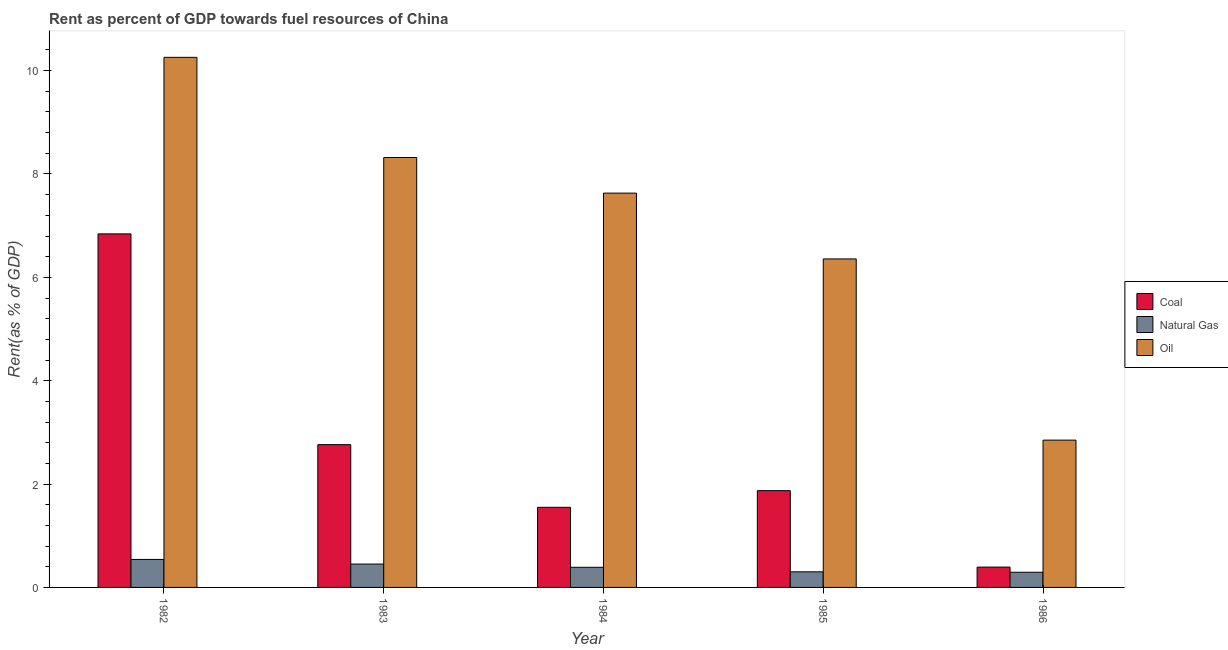How many different coloured bars are there?
Your answer should be compact. 3. How many groups of bars are there?
Your answer should be compact. 5. How many bars are there on the 2nd tick from the left?
Provide a succinct answer. 3. What is the rent towards coal in 1984?
Give a very brief answer. 1.55. Across all years, what is the maximum rent towards oil?
Give a very brief answer. 10.26. Across all years, what is the minimum rent towards oil?
Keep it short and to the point. 2.85. What is the total rent towards oil in the graph?
Your answer should be very brief. 35.41. What is the difference between the rent towards oil in 1982 and that in 1986?
Provide a succinct answer. 7.41. What is the difference between the rent towards coal in 1985 and the rent towards oil in 1984?
Give a very brief answer. 0.32. What is the average rent towards natural gas per year?
Give a very brief answer. 0.4. What is the ratio of the rent towards oil in 1984 to that in 1986?
Give a very brief answer. 2.68. Is the difference between the rent towards oil in 1982 and 1986 greater than the difference between the rent towards coal in 1982 and 1986?
Your response must be concise. No. What is the difference between the highest and the second highest rent towards natural gas?
Keep it short and to the point. 0.09. What is the difference between the highest and the lowest rent towards coal?
Provide a short and direct response. 6.45. In how many years, is the rent towards natural gas greater than the average rent towards natural gas taken over all years?
Make the answer very short. 2. What does the 1st bar from the left in 1983 represents?
Ensure brevity in your answer.  Coal. What does the 3rd bar from the right in 1986 represents?
Make the answer very short. Coal. Are all the bars in the graph horizontal?
Your response must be concise. No. How many years are there in the graph?
Your response must be concise. 5. What is the difference between two consecutive major ticks on the Y-axis?
Ensure brevity in your answer.  2. Does the graph contain any zero values?
Your answer should be very brief. No. Where does the legend appear in the graph?
Offer a terse response. Center right. How many legend labels are there?
Your response must be concise. 3. What is the title of the graph?
Provide a succinct answer. Rent as percent of GDP towards fuel resources of China. What is the label or title of the Y-axis?
Provide a succinct answer. Rent(as % of GDP). What is the Rent(as % of GDP) of Coal in 1982?
Give a very brief answer. 6.84. What is the Rent(as % of GDP) of Natural Gas in 1982?
Provide a short and direct response. 0.54. What is the Rent(as % of GDP) in Oil in 1982?
Provide a succinct answer. 10.26. What is the Rent(as % of GDP) in Coal in 1983?
Offer a very short reply. 2.76. What is the Rent(as % of GDP) of Natural Gas in 1983?
Offer a terse response. 0.45. What is the Rent(as % of GDP) in Oil in 1983?
Offer a very short reply. 8.32. What is the Rent(as % of GDP) of Coal in 1984?
Offer a terse response. 1.55. What is the Rent(as % of GDP) in Natural Gas in 1984?
Give a very brief answer. 0.39. What is the Rent(as % of GDP) in Oil in 1984?
Provide a short and direct response. 7.63. What is the Rent(as % of GDP) in Coal in 1985?
Offer a terse response. 1.87. What is the Rent(as % of GDP) in Natural Gas in 1985?
Provide a succinct answer. 0.3. What is the Rent(as % of GDP) in Oil in 1985?
Offer a terse response. 6.36. What is the Rent(as % of GDP) in Coal in 1986?
Your response must be concise. 0.39. What is the Rent(as % of GDP) in Natural Gas in 1986?
Provide a short and direct response. 0.29. What is the Rent(as % of GDP) in Oil in 1986?
Provide a short and direct response. 2.85. Across all years, what is the maximum Rent(as % of GDP) of Coal?
Your answer should be very brief. 6.84. Across all years, what is the maximum Rent(as % of GDP) of Natural Gas?
Give a very brief answer. 0.54. Across all years, what is the maximum Rent(as % of GDP) in Oil?
Provide a succinct answer. 10.26. Across all years, what is the minimum Rent(as % of GDP) of Coal?
Ensure brevity in your answer.  0.39. Across all years, what is the minimum Rent(as % of GDP) of Natural Gas?
Your response must be concise. 0.29. Across all years, what is the minimum Rent(as % of GDP) of Oil?
Make the answer very short. 2.85. What is the total Rent(as % of GDP) in Coal in the graph?
Keep it short and to the point. 13.42. What is the total Rent(as % of GDP) of Natural Gas in the graph?
Ensure brevity in your answer.  1.98. What is the total Rent(as % of GDP) in Oil in the graph?
Provide a succinct answer. 35.41. What is the difference between the Rent(as % of GDP) in Coal in 1982 and that in 1983?
Your response must be concise. 4.08. What is the difference between the Rent(as % of GDP) in Natural Gas in 1982 and that in 1983?
Give a very brief answer. 0.09. What is the difference between the Rent(as % of GDP) in Oil in 1982 and that in 1983?
Provide a succinct answer. 1.94. What is the difference between the Rent(as % of GDP) of Coal in 1982 and that in 1984?
Your answer should be compact. 5.29. What is the difference between the Rent(as % of GDP) of Natural Gas in 1982 and that in 1984?
Give a very brief answer. 0.15. What is the difference between the Rent(as % of GDP) of Oil in 1982 and that in 1984?
Give a very brief answer. 2.63. What is the difference between the Rent(as % of GDP) in Coal in 1982 and that in 1985?
Provide a succinct answer. 4.97. What is the difference between the Rent(as % of GDP) in Natural Gas in 1982 and that in 1985?
Your answer should be compact. 0.24. What is the difference between the Rent(as % of GDP) in Oil in 1982 and that in 1985?
Ensure brevity in your answer.  3.9. What is the difference between the Rent(as % of GDP) of Coal in 1982 and that in 1986?
Make the answer very short. 6.45. What is the difference between the Rent(as % of GDP) of Natural Gas in 1982 and that in 1986?
Provide a short and direct response. 0.25. What is the difference between the Rent(as % of GDP) of Oil in 1982 and that in 1986?
Give a very brief answer. 7.41. What is the difference between the Rent(as % of GDP) of Coal in 1983 and that in 1984?
Keep it short and to the point. 1.21. What is the difference between the Rent(as % of GDP) of Natural Gas in 1983 and that in 1984?
Ensure brevity in your answer.  0.06. What is the difference between the Rent(as % of GDP) of Oil in 1983 and that in 1984?
Offer a very short reply. 0.69. What is the difference between the Rent(as % of GDP) of Coal in 1983 and that in 1985?
Your response must be concise. 0.89. What is the difference between the Rent(as % of GDP) in Natural Gas in 1983 and that in 1985?
Provide a succinct answer. 0.15. What is the difference between the Rent(as % of GDP) in Oil in 1983 and that in 1985?
Your answer should be very brief. 1.96. What is the difference between the Rent(as % of GDP) in Coal in 1983 and that in 1986?
Provide a succinct answer. 2.37. What is the difference between the Rent(as % of GDP) of Natural Gas in 1983 and that in 1986?
Your answer should be very brief. 0.16. What is the difference between the Rent(as % of GDP) of Oil in 1983 and that in 1986?
Provide a short and direct response. 5.47. What is the difference between the Rent(as % of GDP) in Coal in 1984 and that in 1985?
Make the answer very short. -0.32. What is the difference between the Rent(as % of GDP) in Natural Gas in 1984 and that in 1985?
Make the answer very short. 0.09. What is the difference between the Rent(as % of GDP) in Oil in 1984 and that in 1985?
Your answer should be very brief. 1.27. What is the difference between the Rent(as % of GDP) in Coal in 1984 and that in 1986?
Your answer should be very brief. 1.16. What is the difference between the Rent(as % of GDP) of Natural Gas in 1984 and that in 1986?
Ensure brevity in your answer.  0.1. What is the difference between the Rent(as % of GDP) in Oil in 1984 and that in 1986?
Provide a short and direct response. 4.78. What is the difference between the Rent(as % of GDP) of Coal in 1985 and that in 1986?
Your answer should be very brief. 1.48. What is the difference between the Rent(as % of GDP) of Natural Gas in 1985 and that in 1986?
Your answer should be compact. 0.01. What is the difference between the Rent(as % of GDP) of Oil in 1985 and that in 1986?
Offer a terse response. 3.51. What is the difference between the Rent(as % of GDP) of Coal in 1982 and the Rent(as % of GDP) of Natural Gas in 1983?
Your answer should be very brief. 6.39. What is the difference between the Rent(as % of GDP) of Coal in 1982 and the Rent(as % of GDP) of Oil in 1983?
Keep it short and to the point. -1.48. What is the difference between the Rent(as % of GDP) of Natural Gas in 1982 and the Rent(as % of GDP) of Oil in 1983?
Provide a short and direct response. -7.78. What is the difference between the Rent(as % of GDP) in Coal in 1982 and the Rent(as % of GDP) in Natural Gas in 1984?
Make the answer very short. 6.45. What is the difference between the Rent(as % of GDP) of Coal in 1982 and the Rent(as % of GDP) of Oil in 1984?
Offer a terse response. -0.79. What is the difference between the Rent(as % of GDP) in Natural Gas in 1982 and the Rent(as % of GDP) in Oil in 1984?
Your answer should be very brief. -7.09. What is the difference between the Rent(as % of GDP) in Coal in 1982 and the Rent(as % of GDP) in Natural Gas in 1985?
Your answer should be compact. 6.54. What is the difference between the Rent(as % of GDP) in Coal in 1982 and the Rent(as % of GDP) in Oil in 1985?
Offer a terse response. 0.48. What is the difference between the Rent(as % of GDP) in Natural Gas in 1982 and the Rent(as % of GDP) in Oil in 1985?
Provide a short and direct response. -5.82. What is the difference between the Rent(as % of GDP) of Coal in 1982 and the Rent(as % of GDP) of Natural Gas in 1986?
Give a very brief answer. 6.55. What is the difference between the Rent(as % of GDP) of Coal in 1982 and the Rent(as % of GDP) of Oil in 1986?
Ensure brevity in your answer.  3.99. What is the difference between the Rent(as % of GDP) in Natural Gas in 1982 and the Rent(as % of GDP) in Oil in 1986?
Offer a terse response. -2.31. What is the difference between the Rent(as % of GDP) in Coal in 1983 and the Rent(as % of GDP) in Natural Gas in 1984?
Keep it short and to the point. 2.37. What is the difference between the Rent(as % of GDP) in Coal in 1983 and the Rent(as % of GDP) in Oil in 1984?
Keep it short and to the point. -4.87. What is the difference between the Rent(as % of GDP) in Natural Gas in 1983 and the Rent(as % of GDP) in Oil in 1984?
Ensure brevity in your answer.  -7.18. What is the difference between the Rent(as % of GDP) in Coal in 1983 and the Rent(as % of GDP) in Natural Gas in 1985?
Your response must be concise. 2.46. What is the difference between the Rent(as % of GDP) in Coal in 1983 and the Rent(as % of GDP) in Oil in 1985?
Your answer should be compact. -3.59. What is the difference between the Rent(as % of GDP) of Natural Gas in 1983 and the Rent(as % of GDP) of Oil in 1985?
Offer a terse response. -5.9. What is the difference between the Rent(as % of GDP) of Coal in 1983 and the Rent(as % of GDP) of Natural Gas in 1986?
Keep it short and to the point. 2.47. What is the difference between the Rent(as % of GDP) in Coal in 1983 and the Rent(as % of GDP) in Oil in 1986?
Ensure brevity in your answer.  -0.09. What is the difference between the Rent(as % of GDP) in Natural Gas in 1983 and the Rent(as % of GDP) in Oil in 1986?
Your answer should be compact. -2.4. What is the difference between the Rent(as % of GDP) in Coal in 1984 and the Rent(as % of GDP) in Natural Gas in 1985?
Your answer should be compact. 1.25. What is the difference between the Rent(as % of GDP) in Coal in 1984 and the Rent(as % of GDP) in Oil in 1985?
Offer a very short reply. -4.81. What is the difference between the Rent(as % of GDP) in Natural Gas in 1984 and the Rent(as % of GDP) in Oil in 1985?
Ensure brevity in your answer.  -5.97. What is the difference between the Rent(as % of GDP) of Coal in 1984 and the Rent(as % of GDP) of Natural Gas in 1986?
Provide a short and direct response. 1.26. What is the difference between the Rent(as % of GDP) in Coal in 1984 and the Rent(as % of GDP) in Oil in 1986?
Give a very brief answer. -1.3. What is the difference between the Rent(as % of GDP) of Natural Gas in 1984 and the Rent(as % of GDP) of Oil in 1986?
Offer a very short reply. -2.46. What is the difference between the Rent(as % of GDP) of Coal in 1985 and the Rent(as % of GDP) of Natural Gas in 1986?
Provide a succinct answer. 1.58. What is the difference between the Rent(as % of GDP) of Coal in 1985 and the Rent(as % of GDP) of Oil in 1986?
Your answer should be compact. -0.98. What is the difference between the Rent(as % of GDP) of Natural Gas in 1985 and the Rent(as % of GDP) of Oil in 1986?
Give a very brief answer. -2.55. What is the average Rent(as % of GDP) of Coal per year?
Your answer should be very brief. 2.68. What is the average Rent(as % of GDP) of Natural Gas per year?
Offer a terse response. 0.4. What is the average Rent(as % of GDP) in Oil per year?
Provide a short and direct response. 7.08. In the year 1982, what is the difference between the Rent(as % of GDP) of Coal and Rent(as % of GDP) of Natural Gas?
Give a very brief answer. 6.3. In the year 1982, what is the difference between the Rent(as % of GDP) of Coal and Rent(as % of GDP) of Oil?
Provide a succinct answer. -3.42. In the year 1982, what is the difference between the Rent(as % of GDP) in Natural Gas and Rent(as % of GDP) in Oil?
Make the answer very short. -9.72. In the year 1983, what is the difference between the Rent(as % of GDP) in Coal and Rent(as % of GDP) in Natural Gas?
Offer a very short reply. 2.31. In the year 1983, what is the difference between the Rent(as % of GDP) of Coal and Rent(as % of GDP) of Oil?
Keep it short and to the point. -5.56. In the year 1983, what is the difference between the Rent(as % of GDP) in Natural Gas and Rent(as % of GDP) in Oil?
Keep it short and to the point. -7.87. In the year 1984, what is the difference between the Rent(as % of GDP) of Coal and Rent(as % of GDP) of Natural Gas?
Your response must be concise. 1.16. In the year 1984, what is the difference between the Rent(as % of GDP) in Coal and Rent(as % of GDP) in Oil?
Your answer should be very brief. -6.08. In the year 1984, what is the difference between the Rent(as % of GDP) of Natural Gas and Rent(as % of GDP) of Oil?
Ensure brevity in your answer.  -7.24. In the year 1985, what is the difference between the Rent(as % of GDP) of Coal and Rent(as % of GDP) of Natural Gas?
Offer a terse response. 1.57. In the year 1985, what is the difference between the Rent(as % of GDP) of Coal and Rent(as % of GDP) of Oil?
Give a very brief answer. -4.48. In the year 1985, what is the difference between the Rent(as % of GDP) of Natural Gas and Rent(as % of GDP) of Oil?
Your response must be concise. -6.05. In the year 1986, what is the difference between the Rent(as % of GDP) in Coal and Rent(as % of GDP) in Natural Gas?
Ensure brevity in your answer.  0.1. In the year 1986, what is the difference between the Rent(as % of GDP) in Coal and Rent(as % of GDP) in Oil?
Give a very brief answer. -2.46. In the year 1986, what is the difference between the Rent(as % of GDP) in Natural Gas and Rent(as % of GDP) in Oil?
Make the answer very short. -2.56. What is the ratio of the Rent(as % of GDP) of Coal in 1982 to that in 1983?
Make the answer very short. 2.48. What is the ratio of the Rent(as % of GDP) in Natural Gas in 1982 to that in 1983?
Provide a succinct answer. 1.2. What is the ratio of the Rent(as % of GDP) of Oil in 1982 to that in 1983?
Keep it short and to the point. 1.23. What is the ratio of the Rent(as % of GDP) in Coal in 1982 to that in 1984?
Your response must be concise. 4.41. What is the ratio of the Rent(as % of GDP) in Natural Gas in 1982 to that in 1984?
Give a very brief answer. 1.39. What is the ratio of the Rent(as % of GDP) in Oil in 1982 to that in 1984?
Provide a succinct answer. 1.34. What is the ratio of the Rent(as % of GDP) in Coal in 1982 to that in 1985?
Your answer should be compact. 3.65. What is the ratio of the Rent(as % of GDP) of Natural Gas in 1982 to that in 1985?
Make the answer very short. 1.79. What is the ratio of the Rent(as % of GDP) of Oil in 1982 to that in 1985?
Your response must be concise. 1.61. What is the ratio of the Rent(as % of GDP) in Coal in 1982 to that in 1986?
Provide a succinct answer. 17.4. What is the ratio of the Rent(as % of GDP) of Natural Gas in 1982 to that in 1986?
Keep it short and to the point. 1.84. What is the ratio of the Rent(as % of GDP) in Oil in 1982 to that in 1986?
Provide a short and direct response. 3.6. What is the ratio of the Rent(as % of GDP) in Coal in 1983 to that in 1984?
Your answer should be very brief. 1.78. What is the ratio of the Rent(as % of GDP) in Natural Gas in 1983 to that in 1984?
Your answer should be very brief. 1.16. What is the ratio of the Rent(as % of GDP) of Oil in 1983 to that in 1984?
Ensure brevity in your answer.  1.09. What is the ratio of the Rent(as % of GDP) of Coal in 1983 to that in 1985?
Your answer should be compact. 1.48. What is the ratio of the Rent(as % of GDP) in Natural Gas in 1983 to that in 1985?
Provide a short and direct response. 1.5. What is the ratio of the Rent(as % of GDP) of Oil in 1983 to that in 1985?
Provide a succinct answer. 1.31. What is the ratio of the Rent(as % of GDP) of Coal in 1983 to that in 1986?
Your answer should be compact. 7.03. What is the ratio of the Rent(as % of GDP) of Natural Gas in 1983 to that in 1986?
Give a very brief answer. 1.54. What is the ratio of the Rent(as % of GDP) in Oil in 1983 to that in 1986?
Make the answer very short. 2.92. What is the ratio of the Rent(as % of GDP) in Coal in 1984 to that in 1985?
Keep it short and to the point. 0.83. What is the ratio of the Rent(as % of GDP) of Natural Gas in 1984 to that in 1985?
Your answer should be compact. 1.29. What is the ratio of the Rent(as % of GDP) of Oil in 1984 to that in 1985?
Your answer should be compact. 1.2. What is the ratio of the Rent(as % of GDP) in Coal in 1984 to that in 1986?
Provide a succinct answer. 3.94. What is the ratio of the Rent(as % of GDP) in Natural Gas in 1984 to that in 1986?
Your answer should be compact. 1.33. What is the ratio of the Rent(as % of GDP) in Oil in 1984 to that in 1986?
Give a very brief answer. 2.68. What is the ratio of the Rent(as % of GDP) in Coal in 1985 to that in 1986?
Your answer should be very brief. 4.76. What is the ratio of the Rent(as % of GDP) in Natural Gas in 1985 to that in 1986?
Your response must be concise. 1.03. What is the ratio of the Rent(as % of GDP) in Oil in 1985 to that in 1986?
Make the answer very short. 2.23. What is the difference between the highest and the second highest Rent(as % of GDP) in Coal?
Your response must be concise. 4.08. What is the difference between the highest and the second highest Rent(as % of GDP) of Natural Gas?
Offer a terse response. 0.09. What is the difference between the highest and the second highest Rent(as % of GDP) of Oil?
Ensure brevity in your answer.  1.94. What is the difference between the highest and the lowest Rent(as % of GDP) of Coal?
Your answer should be compact. 6.45. What is the difference between the highest and the lowest Rent(as % of GDP) in Natural Gas?
Your answer should be compact. 0.25. What is the difference between the highest and the lowest Rent(as % of GDP) in Oil?
Offer a terse response. 7.41. 